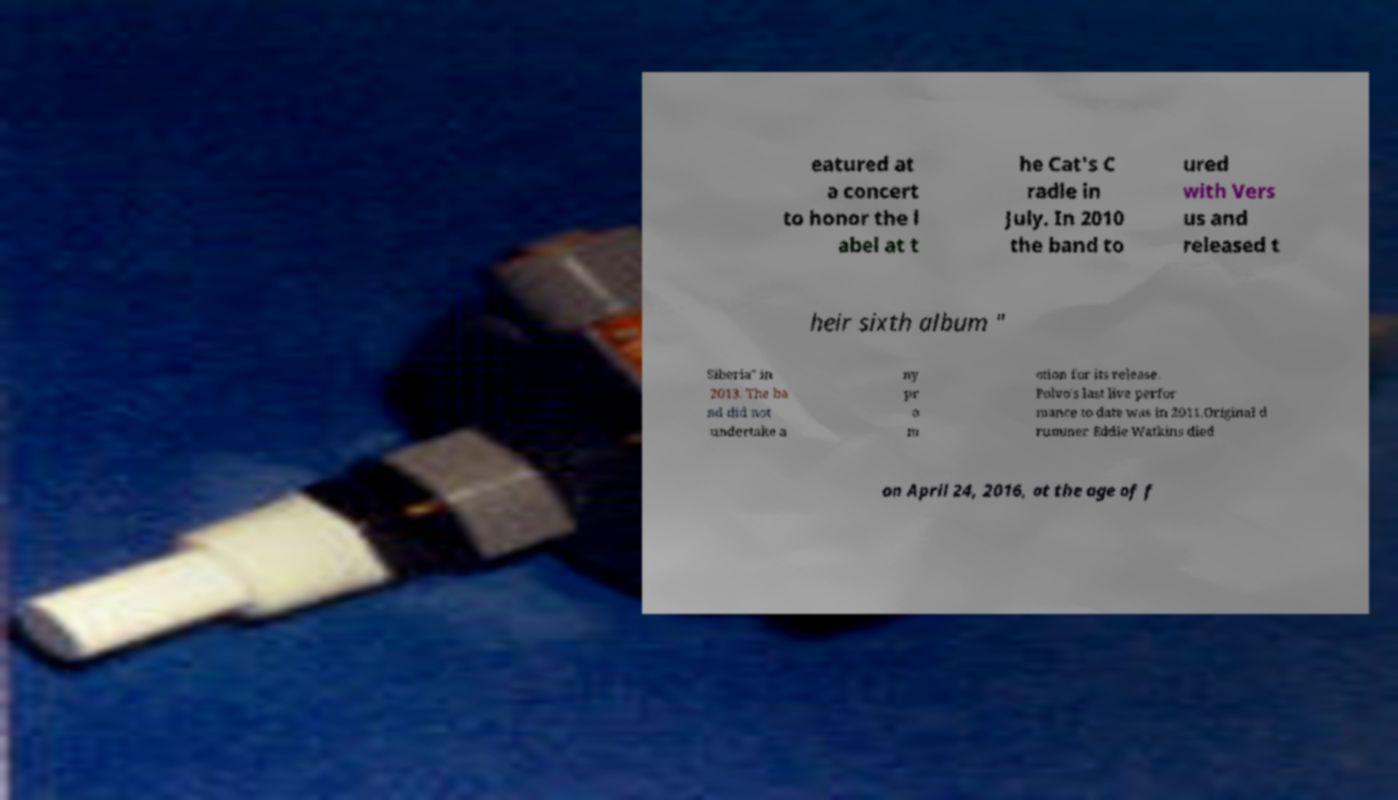Could you extract and type out the text from this image? eatured at a concert to honor the l abel at t he Cat's C radle in July. In 2010 the band to ured with Vers us and released t heir sixth album " Siberia" in 2013. The ba nd did not undertake a ny pr o m otion for its release. Polvo's last live perfor mance to date was in 2011.Original d rummer Eddie Watkins died on April 24, 2016, at the age of f 